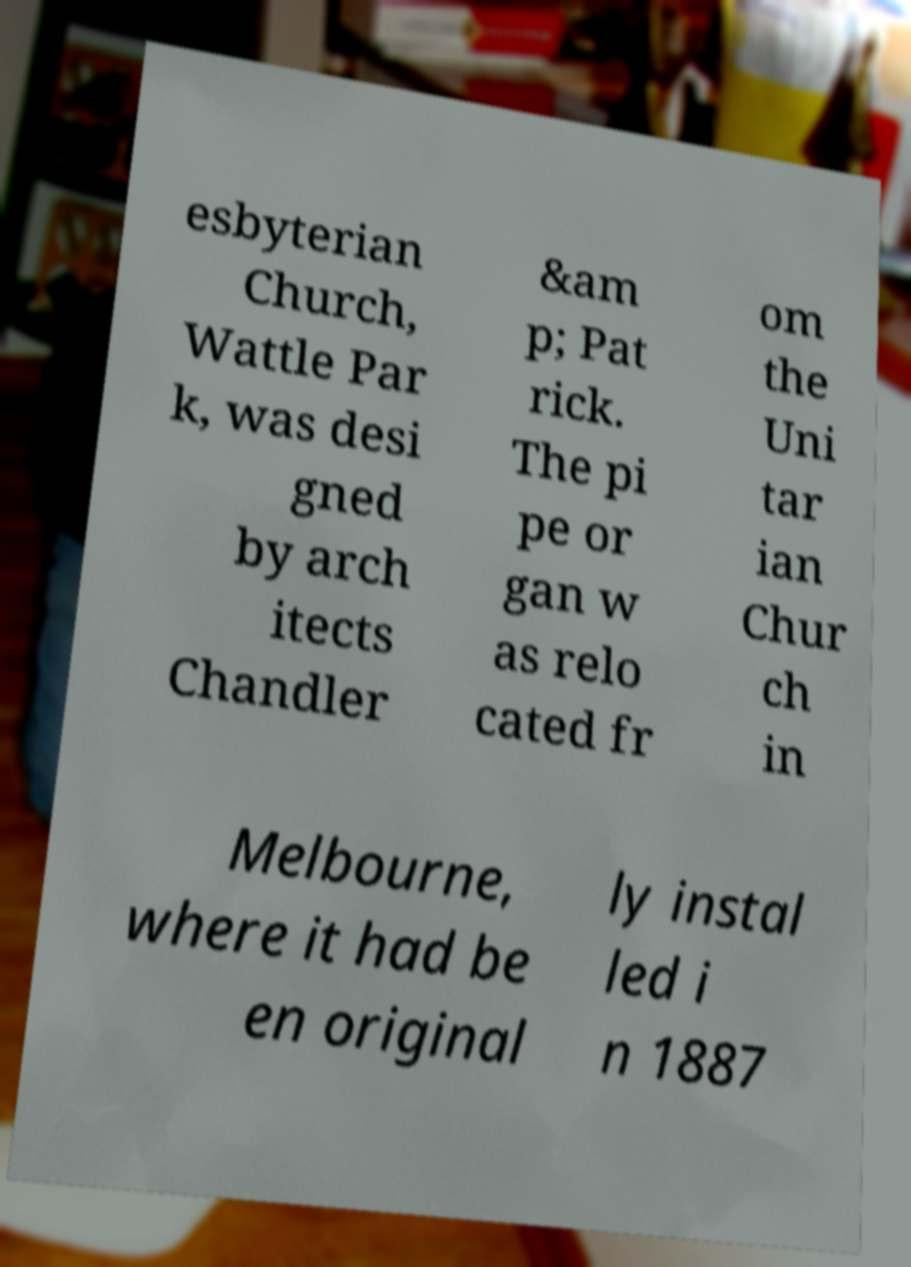Can you accurately transcribe the text from the provided image for me? esbyterian Church, Wattle Par k, was desi gned by arch itects Chandler &am p; Pat rick. The pi pe or gan w as relo cated fr om the Uni tar ian Chur ch in Melbourne, where it had be en original ly instal led i n 1887 